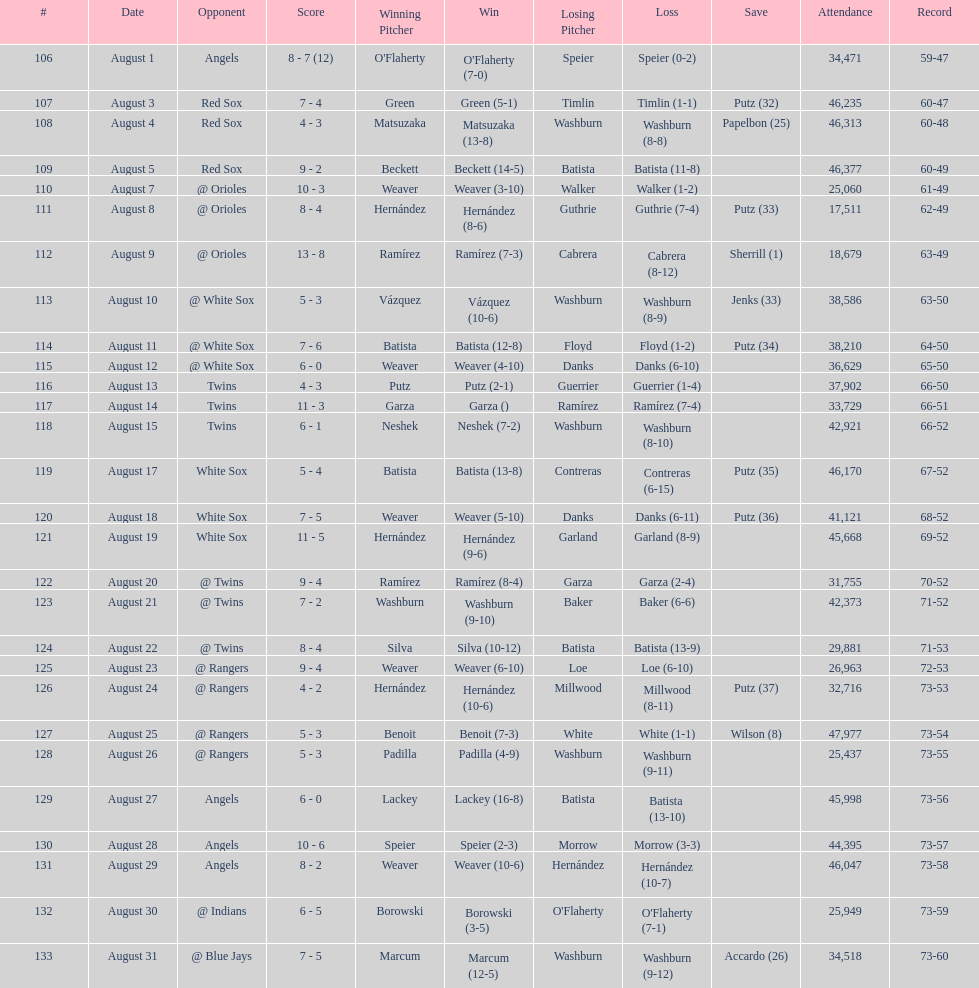What was the total number of games played in august 2007? 28. 